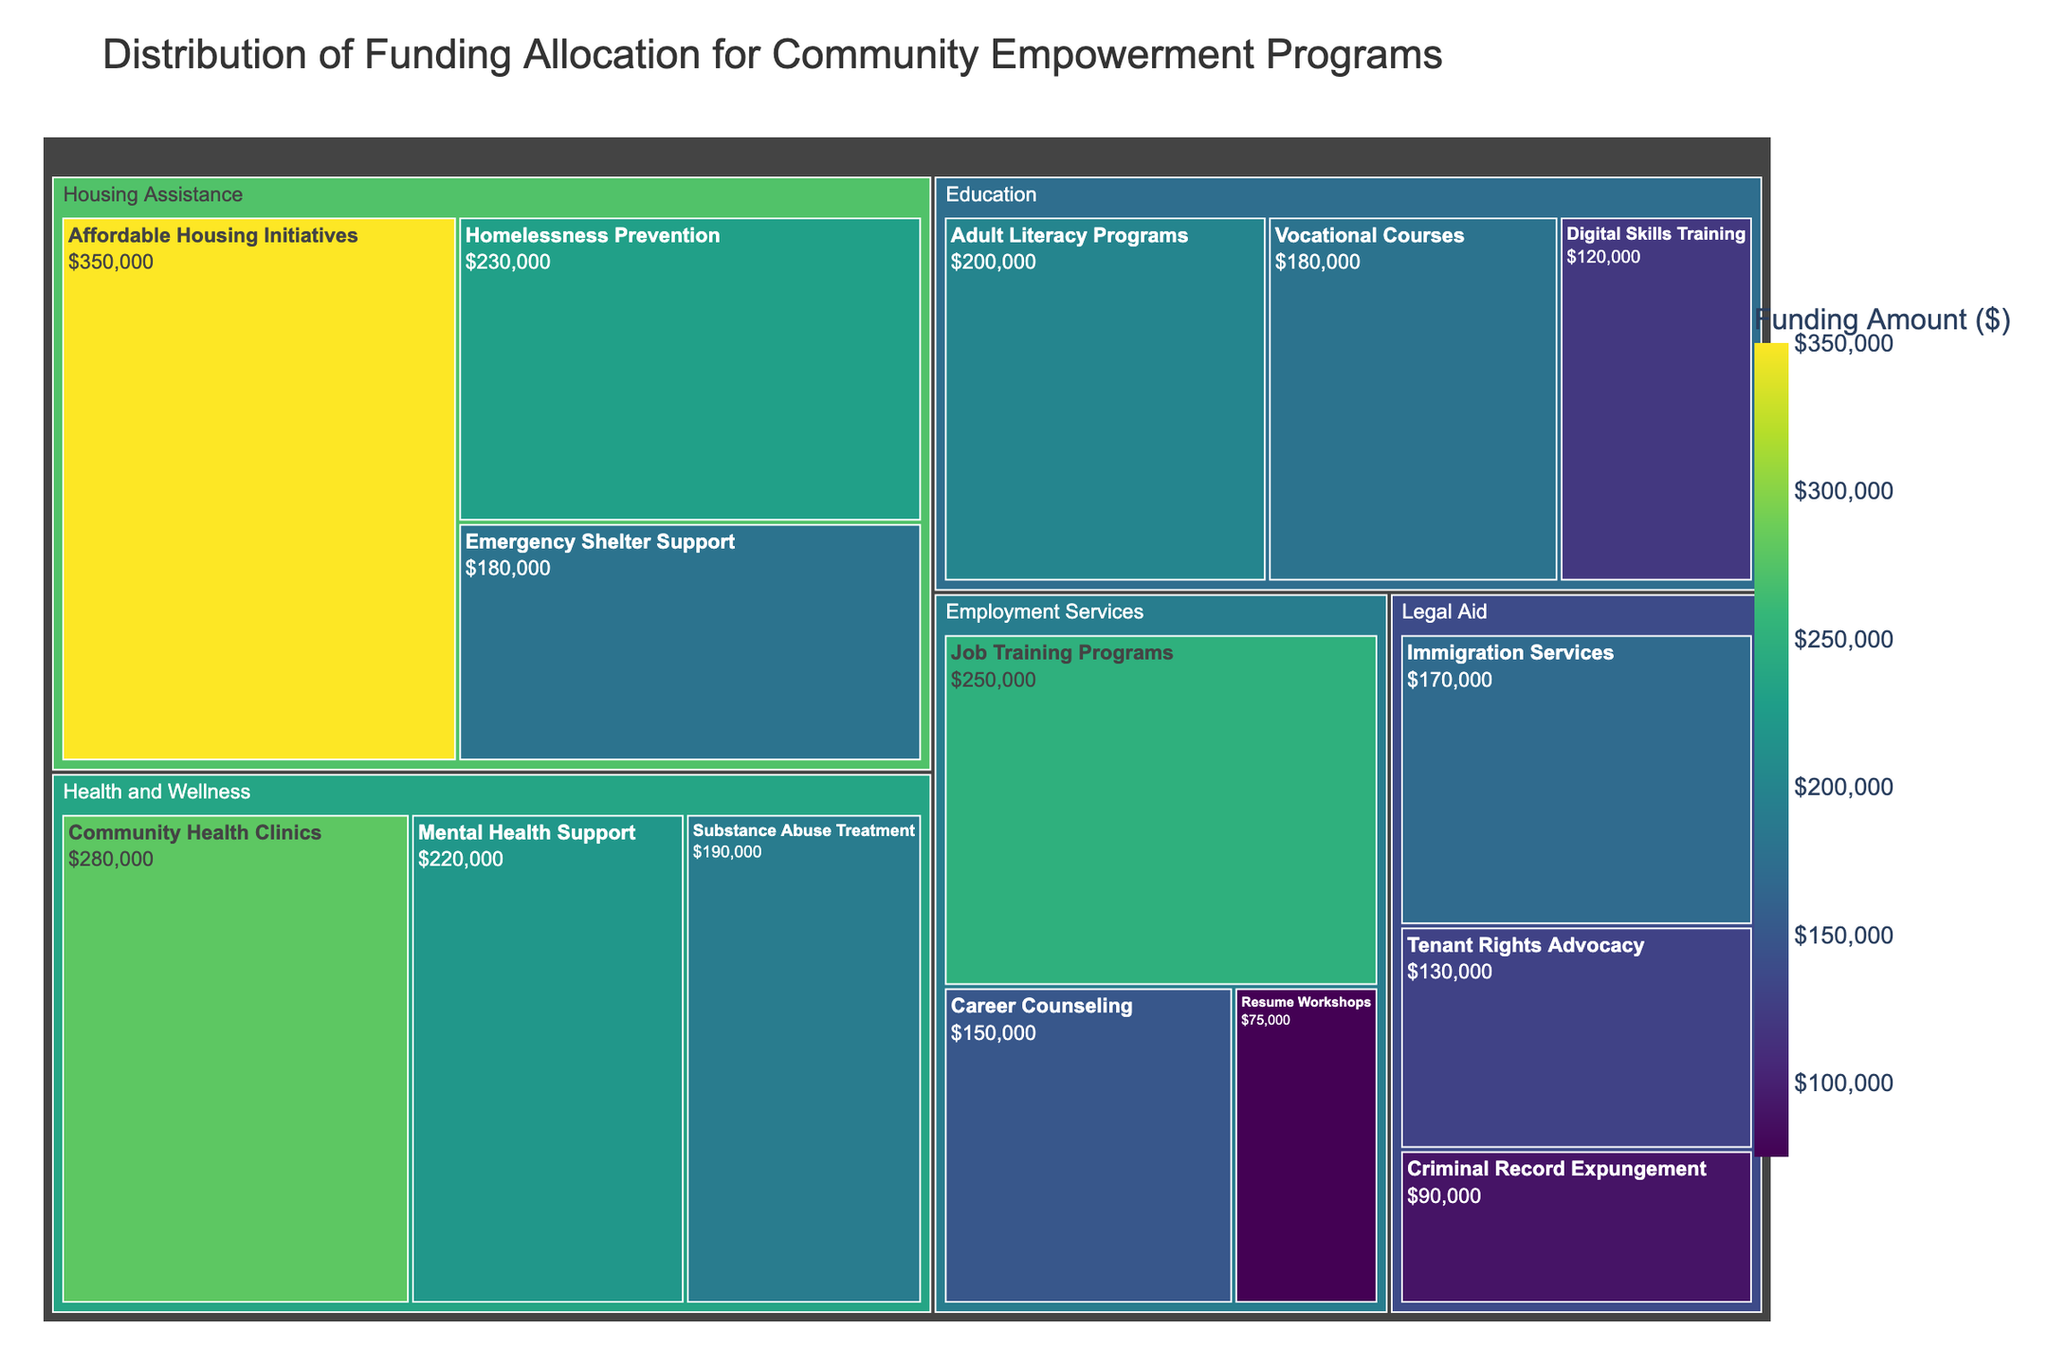How much funding is allocated to the "Job Training Programs" subcategory? The treemap shows that "Job Training Programs" falls under the "Employment Services" category. By looking at the specific subcategory, we can see the funding amount.
Answer: $250,000 Which subcategory within the "Health and Wellness" category received the highest funding? Under the "Health and Wellness" category, compare the funding amounts of the subcategories "Mental Health Support," "Substance Abuse Treatment," and "Community Health Clinics." The one with the highest value is "Community Health Clinics" at $280,000.
Answer: Community Health Clinics What is the total funding amount allocated to the "Education" category? Sum the funding amounts of the subcategories under the "Education" category: "Adult Literacy Programs" ($200,000) + "Vocational Courses" ($180,000) + "Digital Skills Training" ($120,000). So, 200,000 + 180,000 + 120,000 = 500,000.
Answer: $500,000 Compare the funding received by "Affordable Housing Initiatives" and "Homelessness Prevention." Which one received more, and by how much? Under the "Housing Assistance" category, "Affordable Housing Initiatives" received $350,000, while "Homelessness Prevention" received $230,000. The difference is 350,000 - 230,000 = 120,000.
Answer: Affordable Housing Initiatives by $120,000 Which category has the largest total funding allocation? By summing the funds within each category and comparing them, the "Housing Assistance" category has the largest total funding (350,000 + 230,000 + 180,000 = 760,000).
Answer: Housing Assistance How much more funding did "Community Health Clinics" receive compared to "Emergency Shelter Support"? "Community Health Clinics" received $280,000, whereas "Emergency Shelter Support" received $180,000. The difference is 280,000 - 180,000 = 100,000.
Answer: $100,000 What is the average funding amount allocated to subcategories within the "Legal Aid" category? Calculate the mean of the funding amounts for the "Legal Aid" subcategories: (130,000 + 170,000 + 90,000) / 3 = 130,000.
Answer: $130,000 Which category has the smallest total funding allocation and how much is it? By summing the funds within each category and comparing them, the "Legal Aid" category has the smallest total funding (130,000 + 170,000 + 90,000 = 390,000).
Answer: Legal Aid, $390,000 Compare the funding for "Mental Health Support" and "Digital Skills Training." Which subcategory received less, and what is the difference? "Mental Health Support" received $220,000 whereas "Digital Skills Training" received $120,000. The difference is 220,000 - 120,000 = 100,000.
Answer: Digital Skills Training, $100,000 